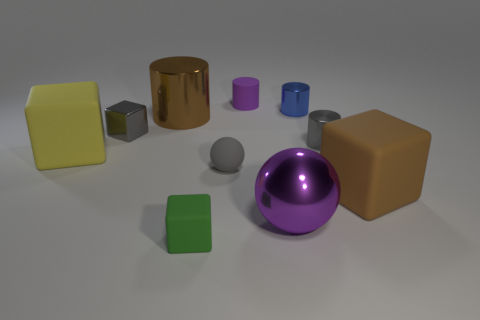There is a cylinder that is the same color as the tiny rubber ball; what material is it?
Keep it short and to the point. Metal. There is a metal object in front of the yellow object; what is its size?
Provide a succinct answer. Large. What number of other yellow matte cubes are the same size as the yellow matte cube?
Your response must be concise. 0. There is a tiny thing that is in front of the blue shiny thing and right of the tiny purple object; what is its material?
Provide a short and direct response. Metal. There is a yellow cube that is the same size as the metal sphere; what material is it?
Make the answer very short. Rubber. How big is the brown object that is in front of the big rubber object behind the brown thing that is to the right of the purple sphere?
Keep it short and to the point. Large. There is a purple object that is made of the same material as the blue object; what size is it?
Give a very brief answer. Large. Does the gray sphere have the same size as the purple rubber cylinder that is behind the big sphere?
Your answer should be very brief. Yes. There is a small gray metal object that is on the left side of the small blue thing; what shape is it?
Keep it short and to the point. Cube. There is a tiny gray shiny object that is to the right of the rubber object that is behind the big yellow matte object; are there any tiny cubes behind it?
Provide a succinct answer. Yes. 